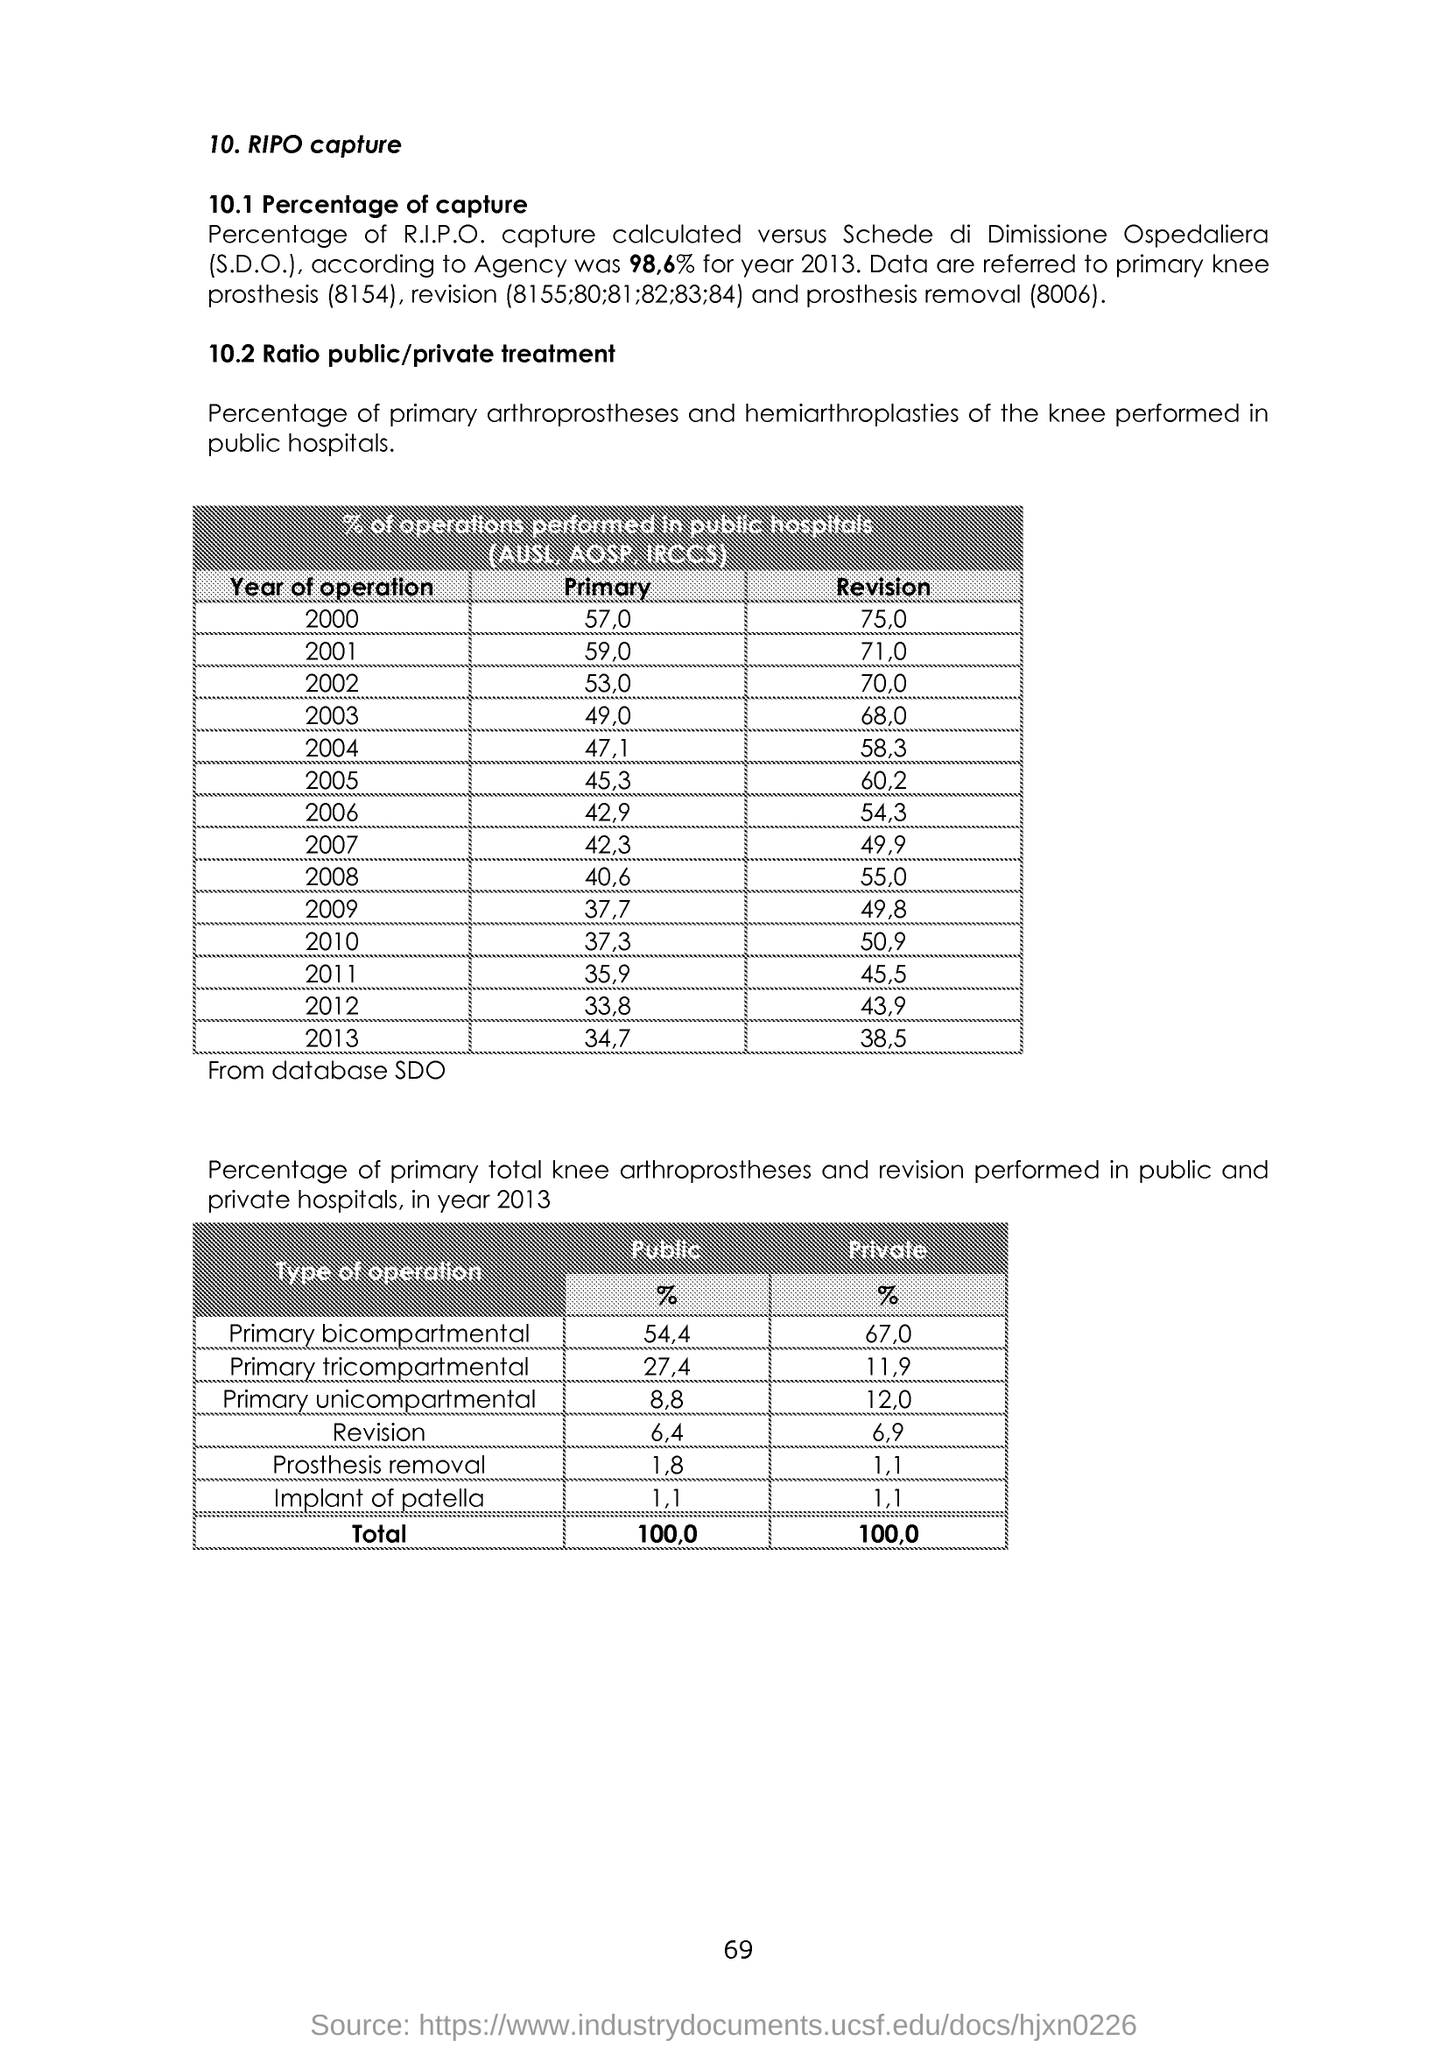Highlight a few significant elements in this photo. The public rate of implanting patella is 1 to 1. The private percentage of primary bicompartmental is 67%. What is the percentage of Revision 6.4? The private percentage of Primary tricompartmental is 11.9%. The public portion of Primary Bicompartmental is approximately 54.4%. 